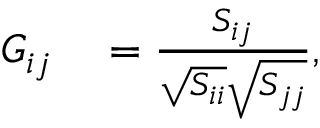Convert formula to latex. <formula><loc_0><loc_0><loc_500><loc_500>\begin{array} { r l } { G _ { i j } } & = \frac { S _ { i j } } { \sqrt { S _ { i i } } \sqrt { S _ { j j } } } , } \end{array}</formula> 